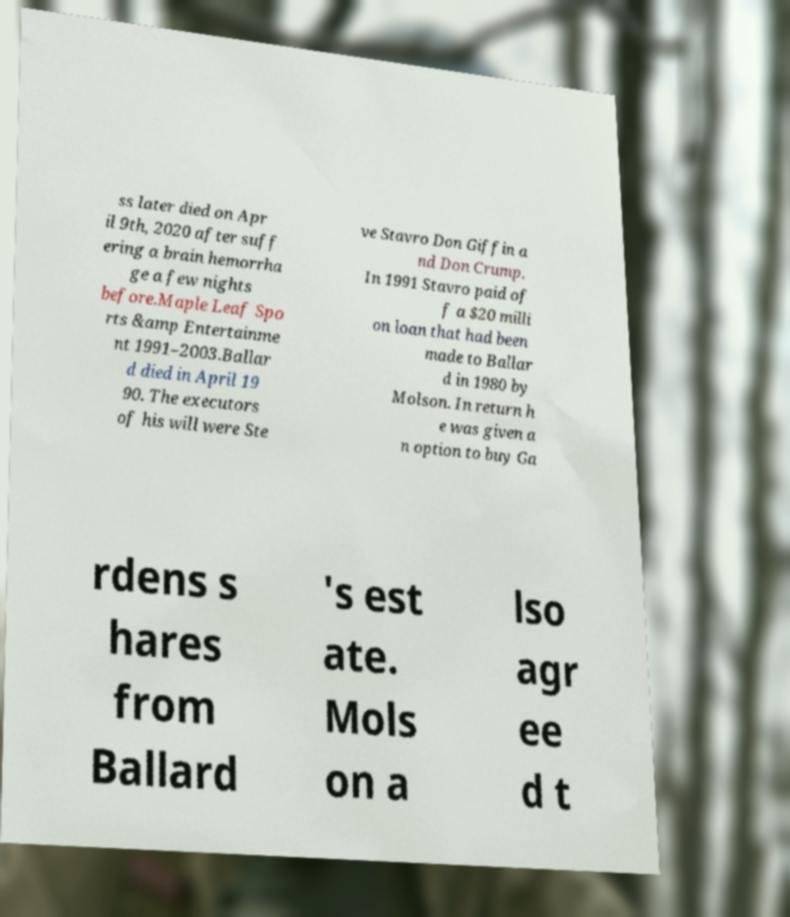What messages or text are displayed in this image? I need them in a readable, typed format. ss later died on Apr il 9th, 2020 after suff ering a brain hemorrha ge a few nights before.Maple Leaf Spo rts &amp Entertainme nt 1991–2003.Ballar d died in April 19 90. The executors of his will were Ste ve Stavro Don Giffin a nd Don Crump. In 1991 Stavro paid of f a $20 milli on loan that had been made to Ballar d in 1980 by Molson. In return h e was given a n option to buy Ga rdens s hares from Ballard 's est ate. Mols on a lso agr ee d t 